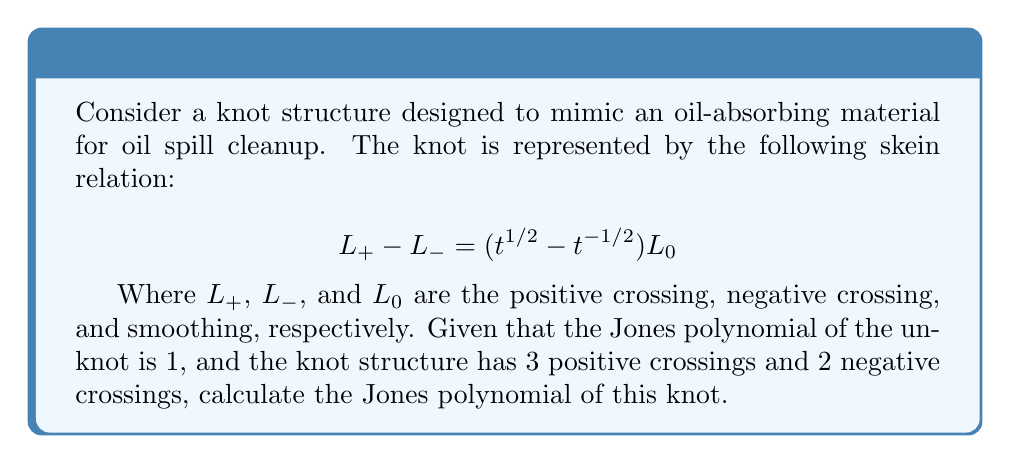Show me your answer to this math problem. 1. Start with the skein relation: $L_+ - L_- = (t^{1/2} - t^{-1/2})L_0$

2. For each crossing, we can write:
   $L_+ = L_- + (t^{1/2} - t^{-1/2})L_0$

3. We have 3 positive crossings and 2 negative crossings. Let's denote the Jones polynomial of our knot as $V(K)$ and the Jones polynomial of the unknot as $V(U) = 1$.

4. For each positive crossing:
   $V(K) = V(K') + (t^{1/2} - t^{-1/2})V(U)$
   Where $K'$ is the knot with one less positive crossing.

5. For each negative crossing:
   $V(K') = V(K) - (t^{1/2} - t^{-1/2})V(U)$
   Where $K'$ is the knot with one less negative crossing.

6. Starting from the unknot, we add 3 positive crossings and 2 negative crossings:
   $V(K) = 1 + 3(t^{1/2} - t^{-1/2}) - 2(t^{1/2} - t^{-1/2})$

7. Simplify:
   $V(K) = 1 + (t^{1/2} - t^{-1/2})$

8. Expand:
   $V(K) = 1 + t^{1/2} - t^{-1/2}$

This is the Jones polynomial of the knot structure mimicking the oil-absorbing material.
Answer: $V(K) = 1 + t^{1/2} - t^{-1/2}$ 